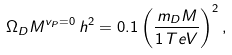Convert formula to latex. <formula><loc_0><loc_0><loc_500><loc_500>\Omega _ { D } M ^ { v _ { P } = 0 } \, h ^ { 2 } = 0 . 1 \left ( \frac { m _ { D } M } { 1 \, T e V } \right ) ^ { 2 } ,</formula> 